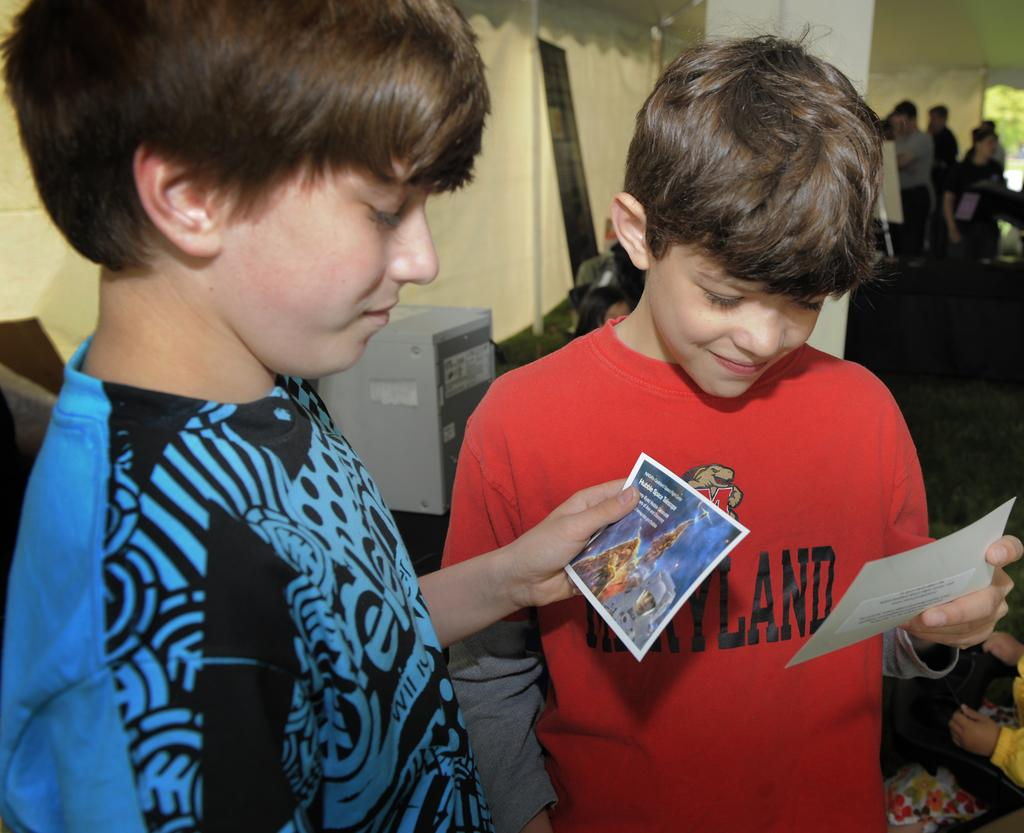How many kids are present in the image? There are two kids standing in the image. What are the kids holding in their hands? The kids are holding a sheet of paper. Can you describe the content of the sheet of paper? There is writing on the sheet of paper. Are there any other people visible in the image? Yes, there are other people in the right corner of the image. What direction is the zephyr blowing in the image? There is no mention of a zephyr or any wind in the image, so it cannot be determined. 